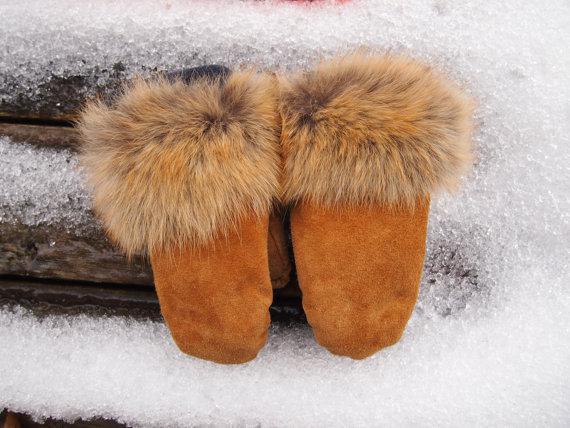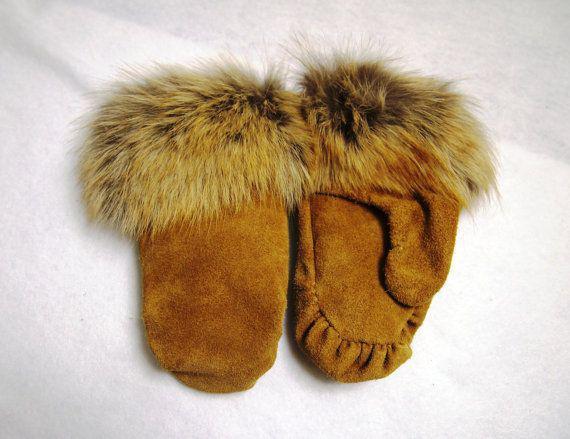The first image is the image on the left, the second image is the image on the right. Assess this claim about the two images: "A tangled cord is part of one image of mitts.". Correct or not? Answer yes or no. No. 